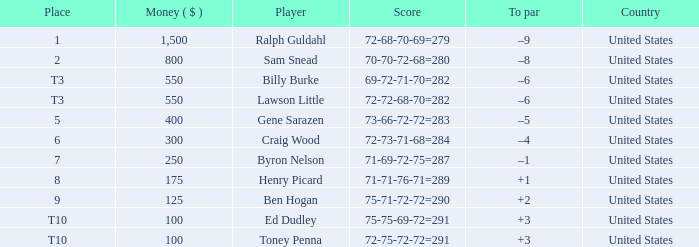Write the full table. {'header': ['Place', 'Money ( $ )', 'Player', 'Score', 'To par', 'Country'], 'rows': [['1', '1,500', 'Ralph Guldahl', '72-68-70-69=279', '–9', 'United States'], ['2', '800', 'Sam Snead', '70-70-72-68=280', '–8', 'United States'], ['T3', '550', 'Billy Burke', '69-72-71-70=282', '–6', 'United States'], ['T3', '550', 'Lawson Little', '72-72-68-70=282', '–6', 'United States'], ['5', '400', 'Gene Sarazen', '73-66-72-72=283', '–5', 'United States'], ['6', '300', 'Craig Wood', '72-73-71-68=284', '–4', 'United States'], ['7', '250', 'Byron Nelson', '71-69-72-75=287', '–1', 'United States'], ['8', '175', 'Henry Picard', '71-71-76-71=289', '+1', 'United States'], ['9', '125', 'Ben Hogan', '75-71-72-72=290', '+2', 'United States'], ['T10', '100', 'Ed Dudley', '75-75-69-72=291', '+3', 'United States'], ['T10', '100', 'Toney Penna', '72-75-72-72=291', '+3', 'United States']]} Which to par has a prize less than $800? –8. 